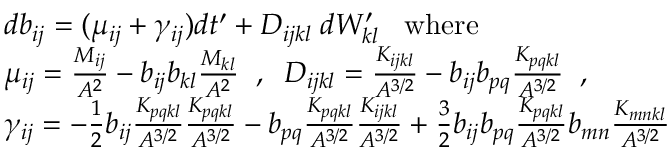Convert formula to latex. <formula><loc_0><loc_0><loc_500><loc_500>\begin{array} { r l } & { d b _ { i j } = ( \mu _ { i j } + \gamma _ { i j } ) d t ^ { \prime } + D _ { i j k l } \, d W _ { k l } ^ { \prime } \, w h e r e } \\ & { \mu _ { i j } = \frac { M _ { i j } } { A ^ { 2 } } - b _ { i j } b _ { k l } \frac { M _ { k l } } { A ^ { 2 } } \, , \, D _ { i j k l } = \frac { K _ { i j k l } } { A ^ { 3 / 2 } } - b _ { i j } b _ { p q } \frac { K _ { p q k l } } { A ^ { 3 / 2 } } \, , } \\ & { \gamma _ { i j } = - \frac { 1 } { 2 } b _ { i j } \frac { K _ { p q k l } } { A ^ { 3 / 2 } } \frac { K _ { p q k l } } { A ^ { 3 / 2 } } - b _ { p q } \frac { K _ { p q k l } } { A ^ { 3 / 2 } } \frac { K _ { i j k l } } { A ^ { 3 / 2 } } + \frac { 3 } { 2 } b _ { i j } b _ { p q } \frac { K _ { p q k l } } { A ^ { 3 / 2 } } b _ { m n } \frac { K _ { m n k l } } { A ^ { 3 / 2 } } } \end{array}</formula> 